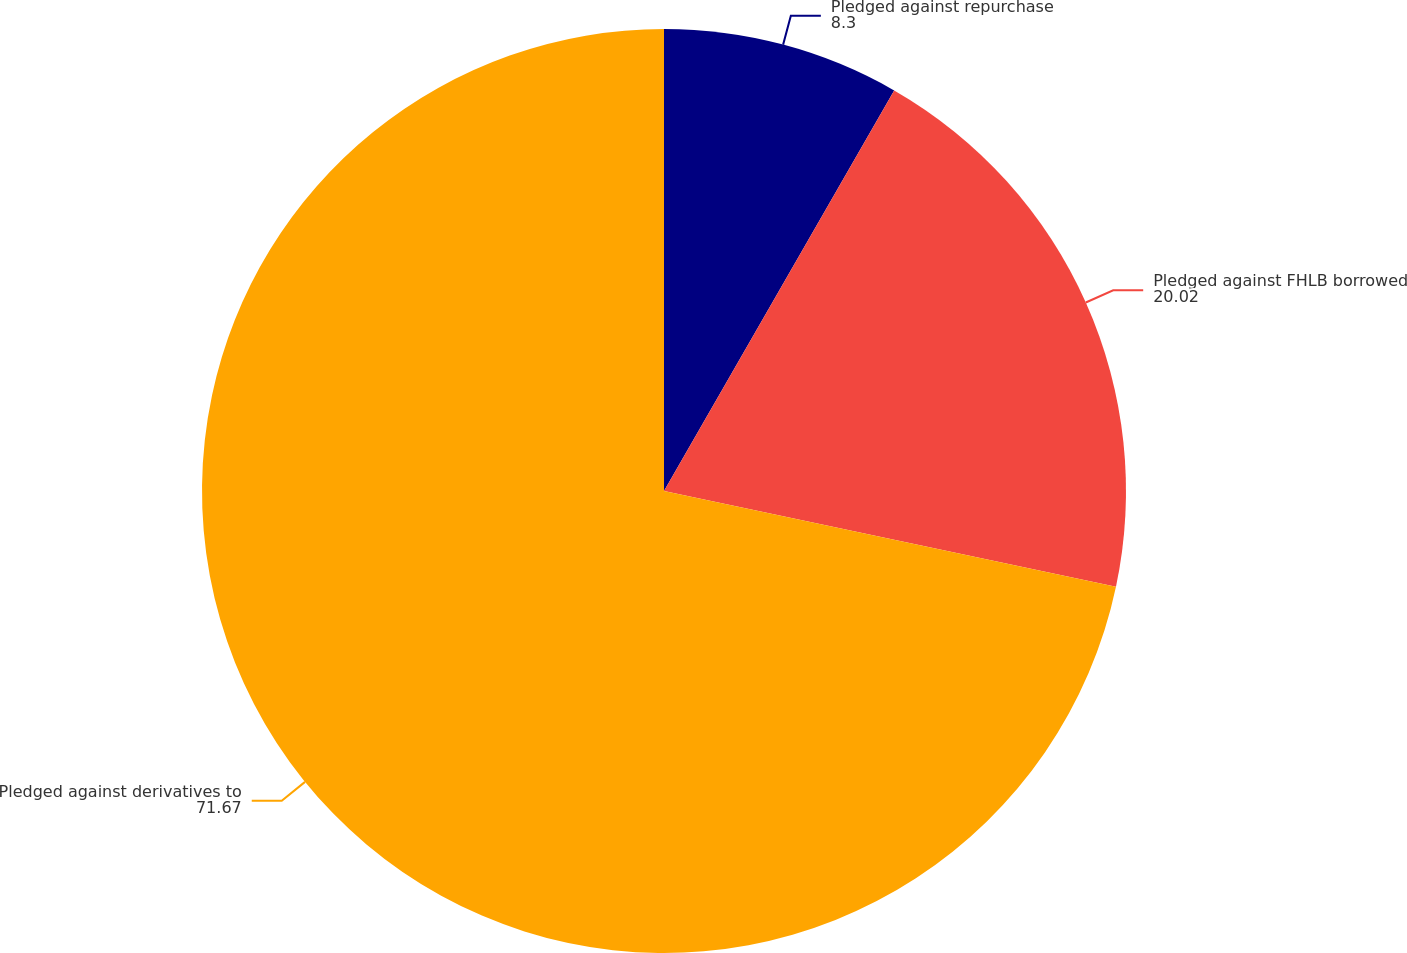<chart> <loc_0><loc_0><loc_500><loc_500><pie_chart><fcel>Pledged against repurchase<fcel>Pledged against FHLB borrowed<fcel>Pledged against derivatives to<nl><fcel>8.3%<fcel>20.02%<fcel>71.67%<nl></chart> 